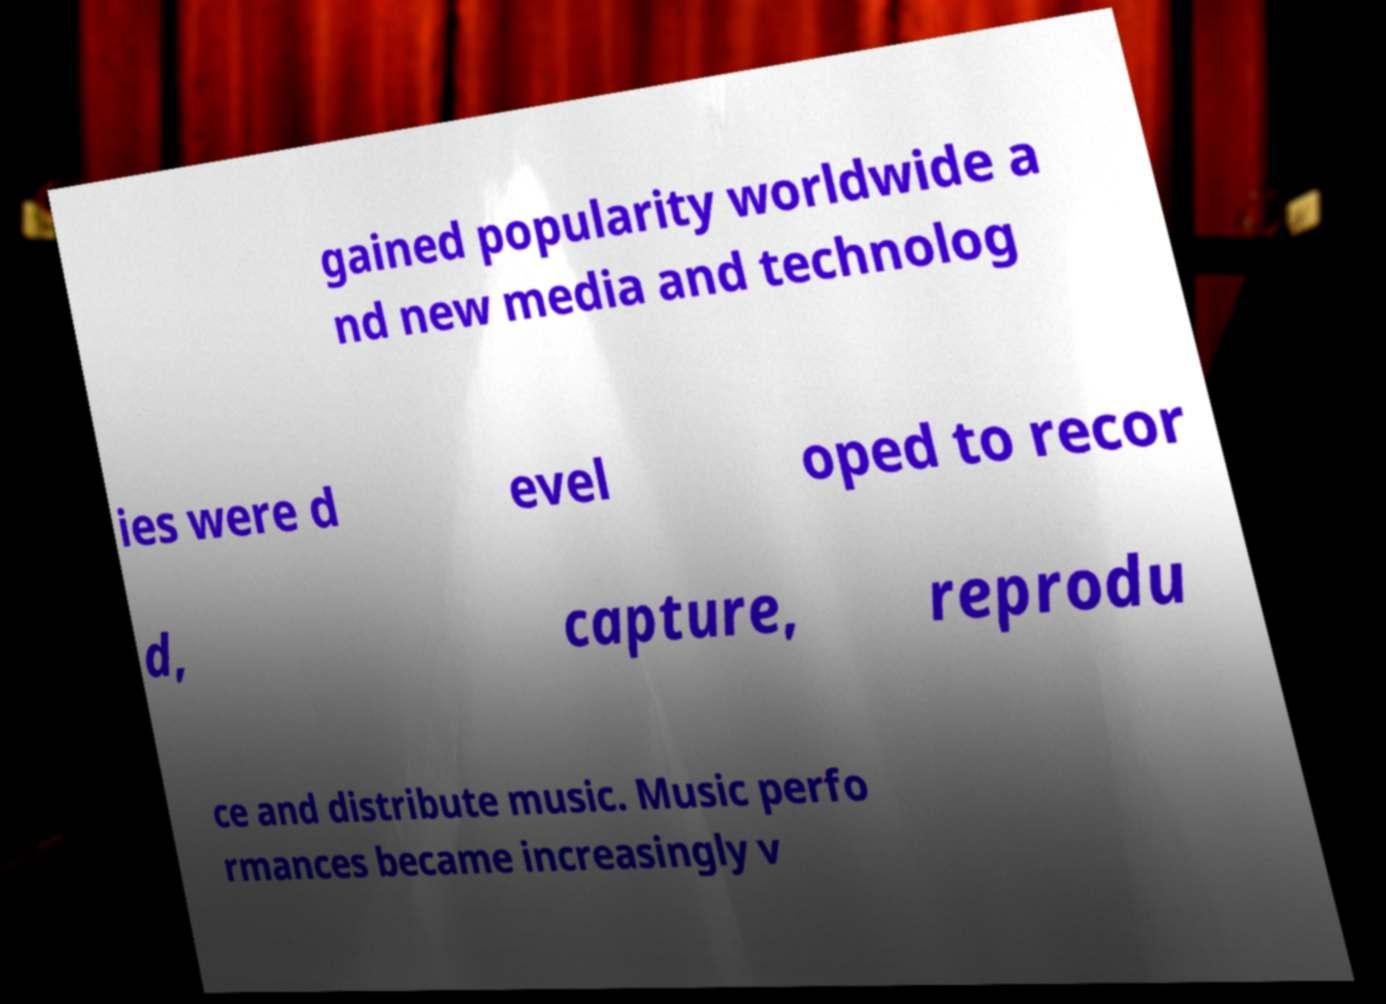What messages or text are displayed in this image? I need them in a readable, typed format. gained popularity worldwide a nd new media and technolog ies were d evel oped to recor d, capture, reprodu ce and distribute music. Music perfo rmances became increasingly v 